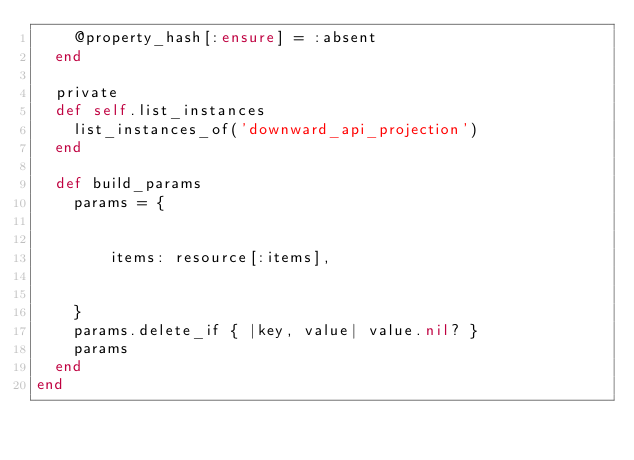Convert code to text. <code><loc_0><loc_0><loc_500><loc_500><_Ruby_>    @property_hash[:ensure] = :absent
  end

  private
  def self.list_instances
    list_instances_of('downward_api_projection')
  end

  def build_params
    params = {
    
      
        items: resource[:items],
      
    
    }
    params.delete_if { |key, value| value.nil? }
    params
  end
end
</code> 